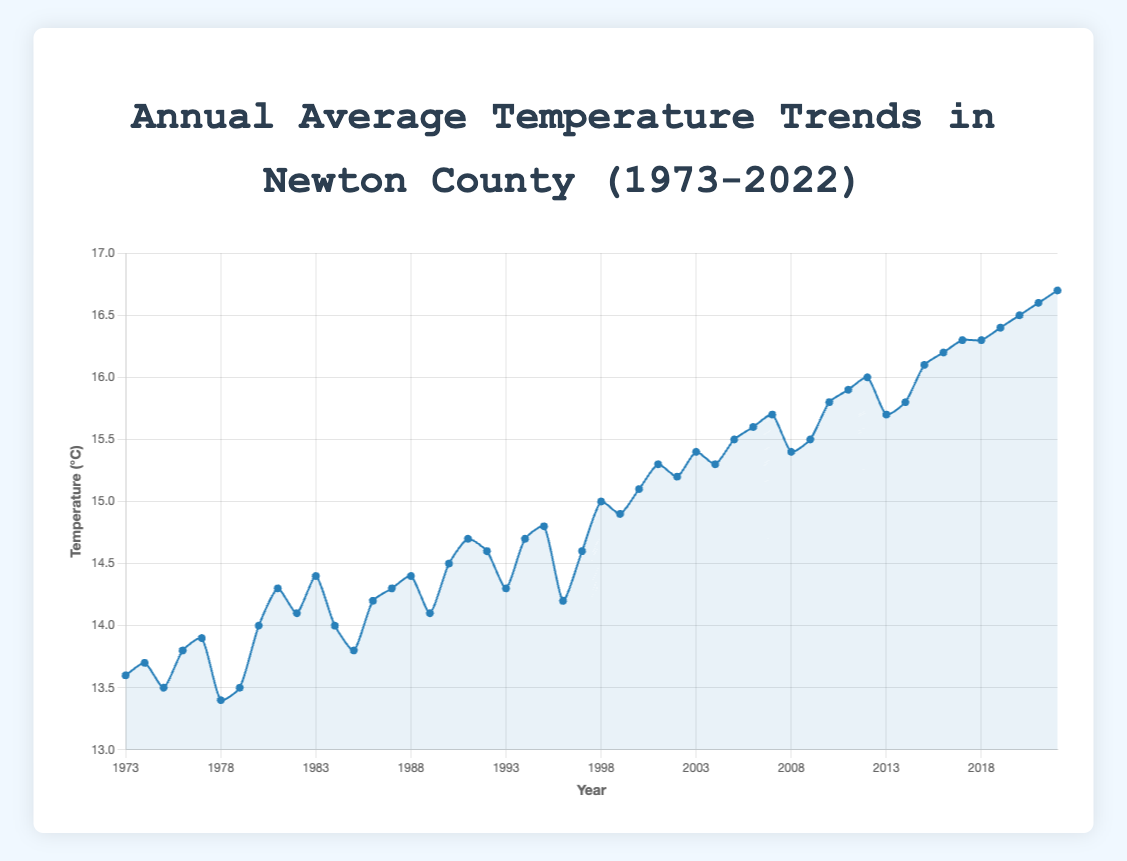Which year had the highest annual average temperature? By scanning the graph, we find that the highest point on the plot is in the year 2022 with a temperature of 16.7°C
Answer: 2022 How much did the temperature increase from 1973 to 2022? The temperature in 1973 was 13.6°C and in 2022 it was 16.7°C. The increase is 16.7°C - 13.6°C = 3.1°C
Answer: 3.1°C Which decades show the most significant temperature increase? By looking at the slopes of different segments of the line chart, it is evident that the most significant rise occurs between 1990 and 2022
Answer: 1990-2022 What was the average annual temperature in the decade of the 2000s (2000-2009)? Sum up the annual temperatures from 2000 to 2009 and divide by 10: (15.1 + 15.3 + 15.2 + 15.4 + 15.3 + 15.5 + 15.6 + 15.7 + 15.4 + 15.5) / 10 = 15.40°C
Answer: 15.4°C Which year had the most significant drop in temperature compared to the previous year? The most significant drop is between 1999 (14.9°C) and 2000 (15.1°C) with a decrease of 0.3°C
Answer: 2004 What is the temperature difference between the years with the highest and lowest temperatures within the dataset? The highest temperature is 16.7°C (2022) and the lowest is 13.4°C (1978). The difference is 16.7°C - 13.4°C = 3.3°C
Answer: 3.3°C Between which consecutive years did the temperature remain nearly constant? Observing the plot, the temperature remained nearly constant between 2017 (16.3°C) and 2018 (16.3°C)
Answer: 2017 and 2018 Which period shows a generally increasing but fluctuating temperature trend? From the early 1970s to mid-1990s, the temperature increases overall but fluctuates regularly
Answer: 1973 to 1997 